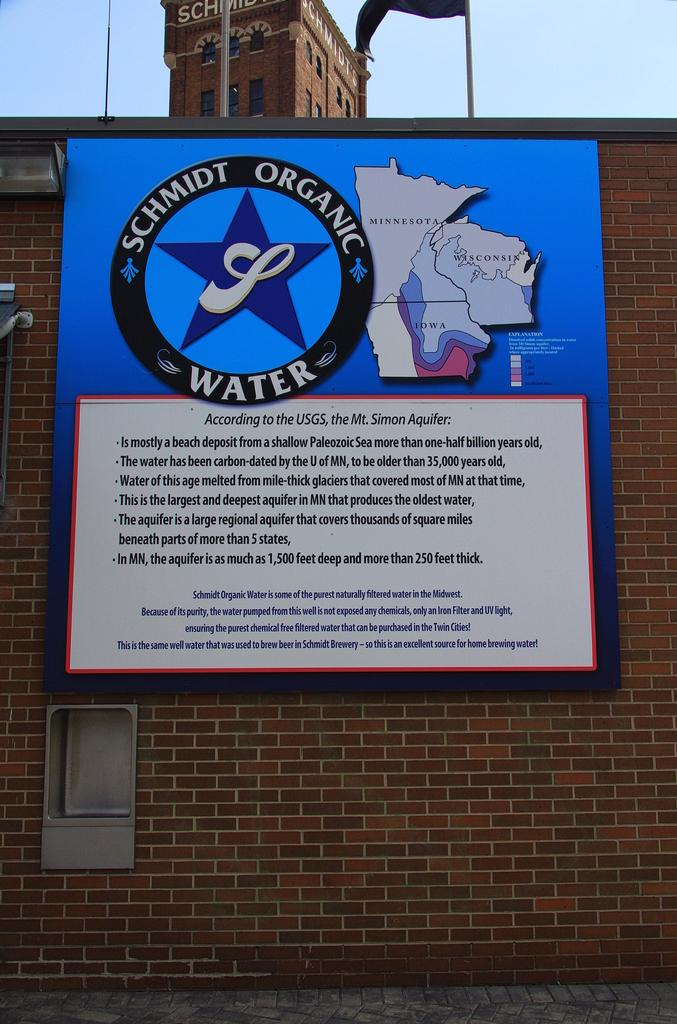What is present on the wall in the image? There is a board with text on the wall. What else can be seen on the wall? There is a flag in the image. What type of structure is visible in the image? There is a building in the image. Can you describe the light in the image? There is a light in the image. What is visible in the background of the image? The sky is visible in the background of the image. Can you tell me how many times the camera has been used to take a bite out of the blade in the image? There is no camera, bite, or blade present in the image. 